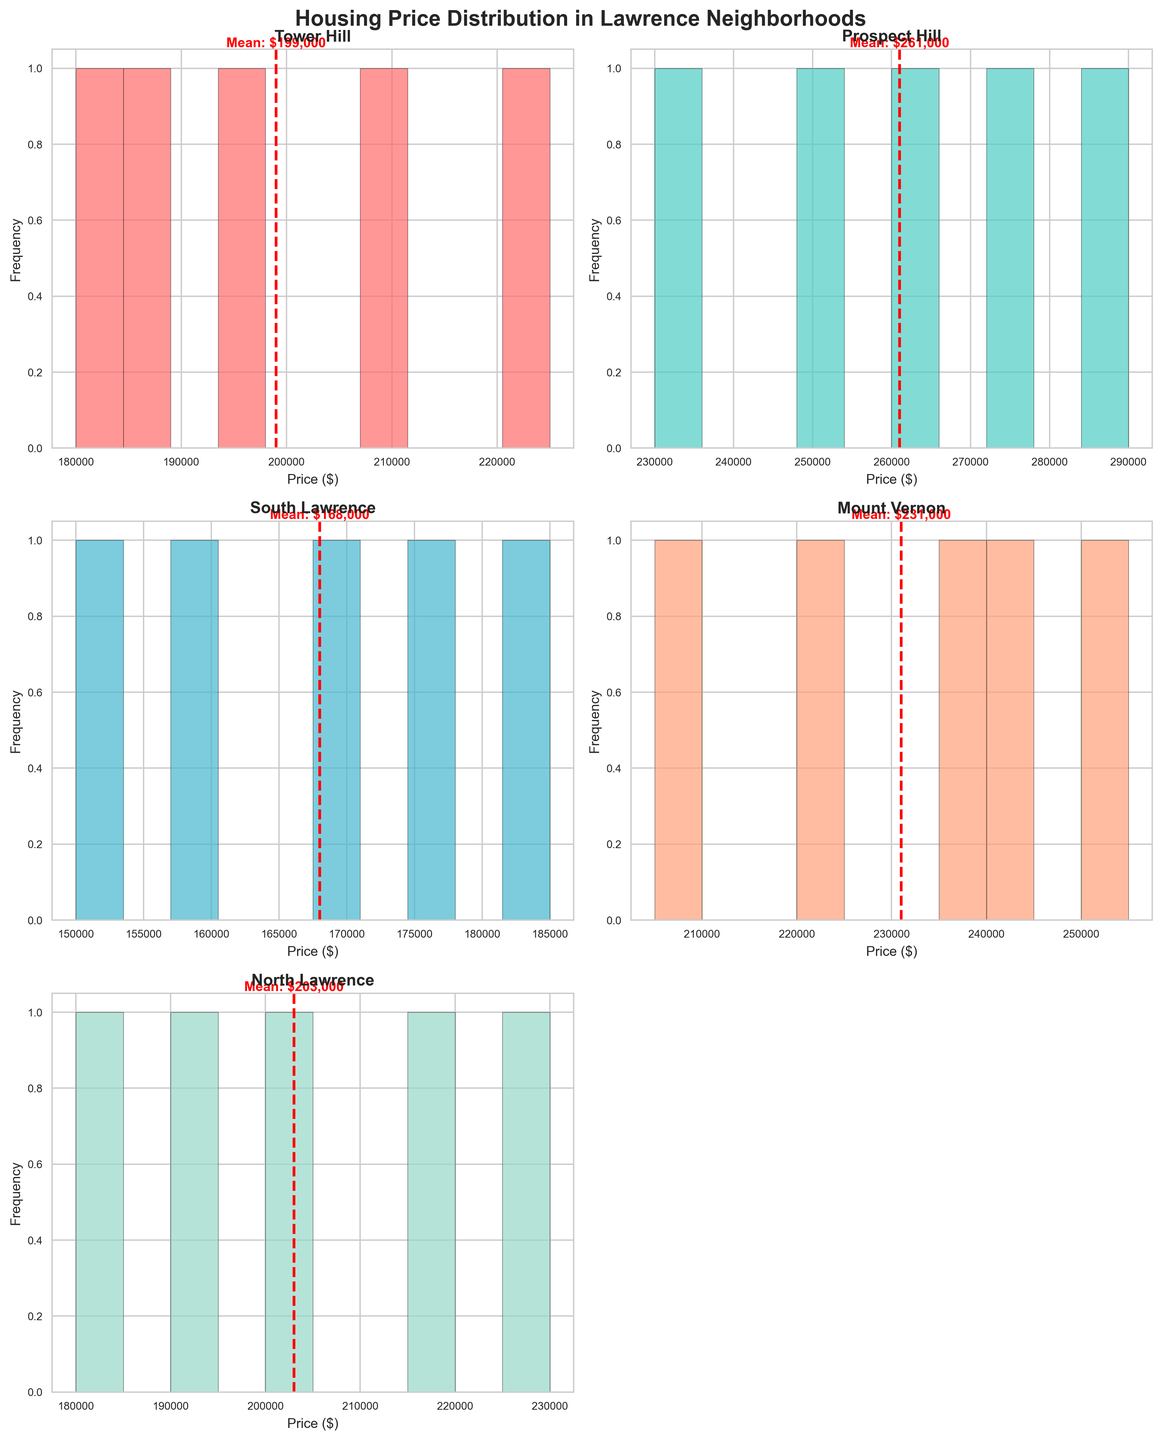What is the title of the figure? The title is usually located at the top of the figure. In this case, the title is 'Housing Price Distribution in Lawrence Neighborhoods'.
Answer: Housing Price Distribution in Lawrence Neighborhoods Which neighborhood has the darkest blue-colored histogram? The neighborhood with the darkest blue histogram can be identified by looking at the color used for each subplot. In this figure, almost all colors are pastel except for the 'North Lawrence' which is in a darker shade.
Answer: North Lawrence How many bins are used in each histogram? By looking at the histograms, each of them appears to be divided into distinct segments or bars. The number of these bars in each histogram is 10.
Answer: 10 Which neighborhood has the highest mean housing price? The mean price is indicated by a red dashed line in each subplot. By comparing the positions of these lines across all histograms, 'Prospect Hill' has the highest mean housing price.
Answer: Prospect Hill What is the mean housing price in South Lawrence? The mean price is indicated by the red dashed line in the 'South Lawrence' histogram. The mean price is displayed next to the line and can be read off directly. The approximate mean price for South Lawrence is $168,000.
Answer: $168,000 Which neighborhood has the widest range of housing prices? The range can be determined by looking at the spread of the bars in each histogram. 'Prospect Hill' has bars that are spread more widely compared to other neighborhoods, indicating a wider range of housing prices.
Answer: Prospect Hill Is the mean housing price in North Lawrence higher or lower than in Tower Hill? By comparing the positions of the red dashed lines, it is evident that the mean price line for 'North Lawrence' is slightly higher than for 'Tower Hill'.
Answer: Higher How many neighborhoods have mean prices above $200,000? We count the number of neighborhoods where the red dashed line, indicating the mean price, falls above the $200,000 mark on the x-axis. 'Tower Hill', 'Prospect Hill', 'Mount Vernon', and 'North Lawrence' all have mean prices above this value.
Answer: 4 Which neighborhood's histogram has the most data points visible? By counting the bars and their heights in the histograms, each bar represents multiple data points. All neighborhoods shown seem to have five data points.
Answer: All have 5 data points What is the color used for the histogram of Mount Vernon? The histogram for 'Mount Vernon' can be identified visually and the color used for it can be described. The color is light orange.
Answer: Light orange 